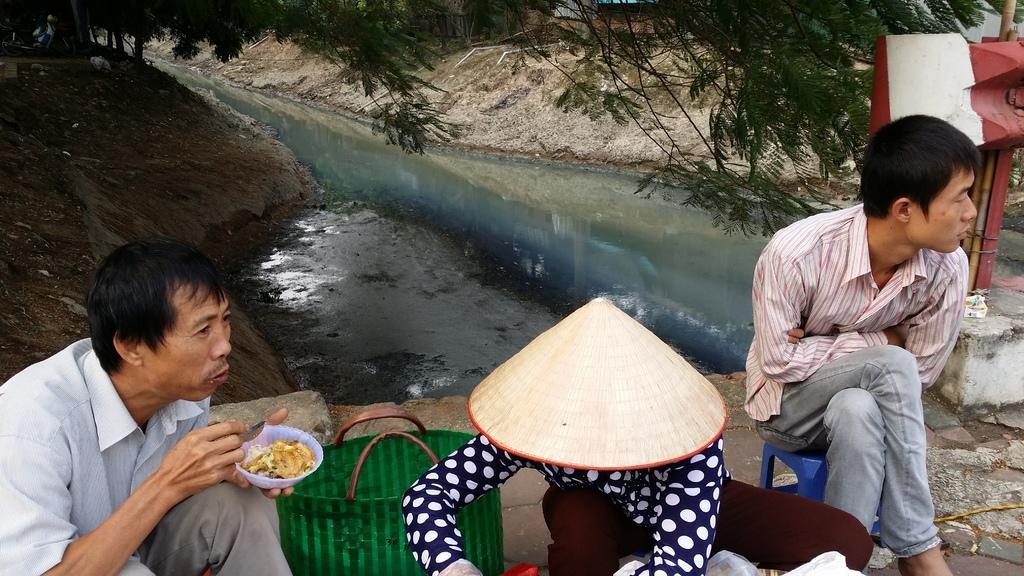Describe this image in one or two sentences. In the foreground of the image there are three persons sitting on chairs. There is a green color bag. In the center of the image there is water. At the top of the image there is a tree branch. To the right side of the image there are poles. 